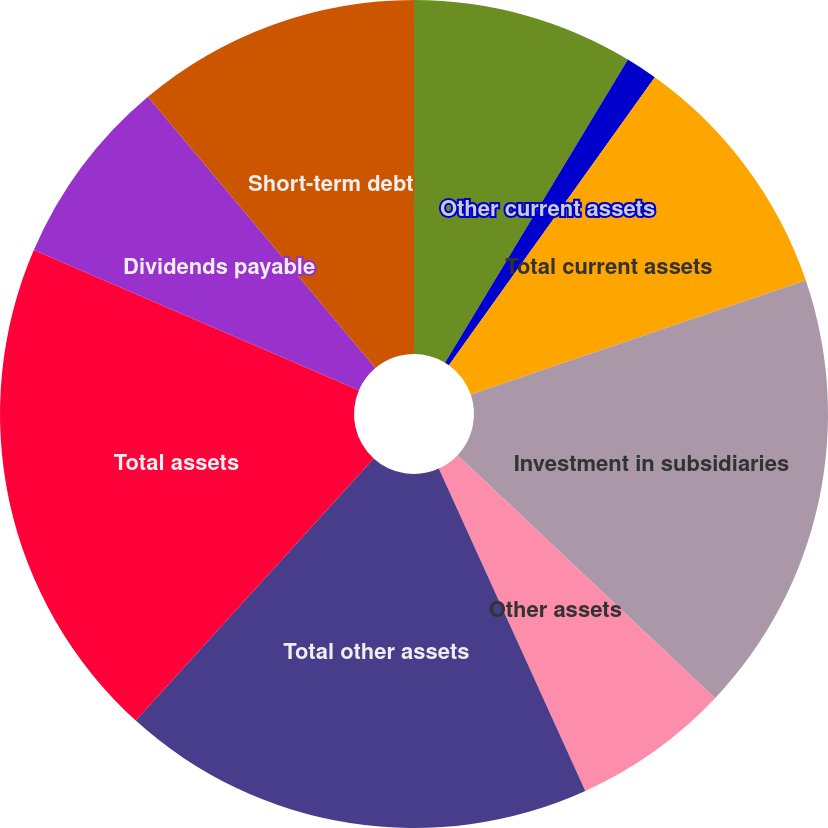Convert chart to OTSL. <chart><loc_0><loc_0><loc_500><loc_500><pie_chart><fcel>Cash and cash equivalents<fcel>Accounts receivable from<fcel>Other current assets<fcel>Total current assets<fcel>Investment in subsidiaries<fcel>Other assets<fcel>Total other assets<fcel>Total assets<fcel>Dividends payable<fcel>Short-term debt<nl><fcel>0.0%<fcel>8.64%<fcel>1.24%<fcel>9.88%<fcel>17.28%<fcel>6.17%<fcel>18.52%<fcel>19.75%<fcel>7.41%<fcel>11.11%<nl></chart> 